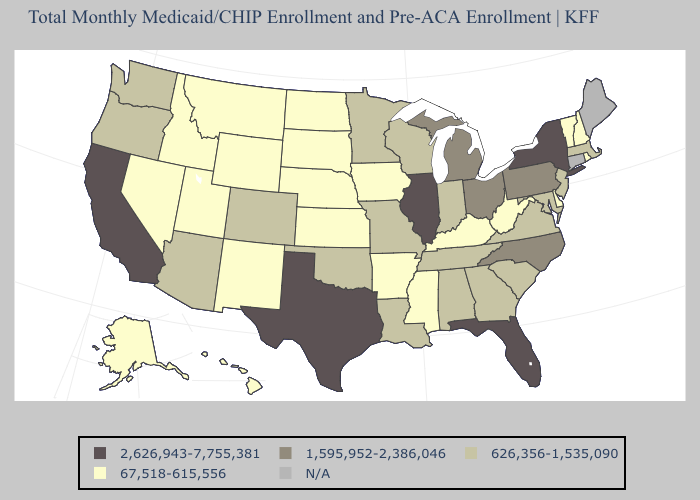Does California have the lowest value in the West?
Answer briefly. No. Which states have the lowest value in the MidWest?
Write a very short answer. Iowa, Kansas, Nebraska, North Dakota, South Dakota. Name the states that have a value in the range N/A?
Concise answer only. Connecticut, Maine. What is the value of Virginia?
Write a very short answer. 626,356-1,535,090. Name the states that have a value in the range 626,356-1,535,090?
Keep it brief. Alabama, Arizona, Colorado, Georgia, Indiana, Louisiana, Maryland, Massachusetts, Minnesota, Missouri, New Jersey, Oklahoma, Oregon, South Carolina, Tennessee, Virginia, Washington, Wisconsin. What is the lowest value in the USA?
Keep it brief. 67,518-615,556. Does the first symbol in the legend represent the smallest category?
Quick response, please. No. Among the states that border California , does Nevada have the lowest value?
Quick response, please. Yes. Which states have the highest value in the USA?
Be succinct. California, Florida, Illinois, New York, Texas. Among the states that border Nebraska , does Missouri have the lowest value?
Keep it brief. No. Does New York have the highest value in the Northeast?
Write a very short answer. Yes. What is the value of Michigan?
Short answer required. 1,595,952-2,386,046. Name the states that have a value in the range 67,518-615,556?
Answer briefly. Alaska, Arkansas, Delaware, Hawaii, Idaho, Iowa, Kansas, Kentucky, Mississippi, Montana, Nebraska, Nevada, New Hampshire, New Mexico, North Dakota, Rhode Island, South Dakota, Utah, Vermont, West Virginia, Wyoming. Name the states that have a value in the range 626,356-1,535,090?
Be succinct. Alabama, Arizona, Colorado, Georgia, Indiana, Louisiana, Maryland, Massachusetts, Minnesota, Missouri, New Jersey, Oklahoma, Oregon, South Carolina, Tennessee, Virginia, Washington, Wisconsin. 